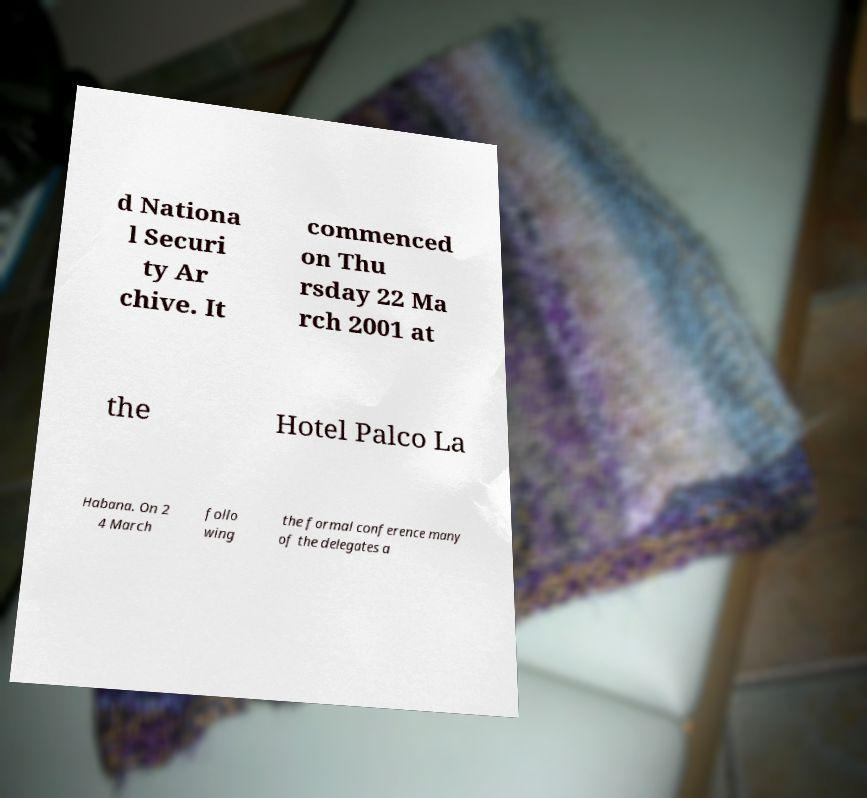Could you assist in decoding the text presented in this image and type it out clearly? d Nationa l Securi ty Ar chive. It commenced on Thu rsday 22 Ma rch 2001 at the Hotel Palco La Habana. On 2 4 March follo wing the formal conference many of the delegates a 